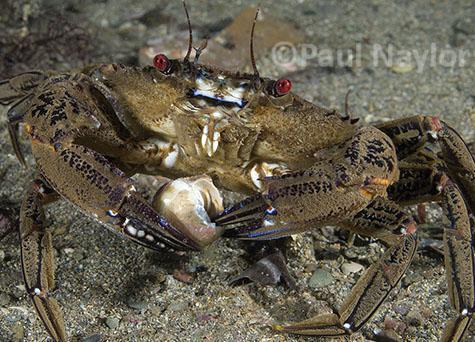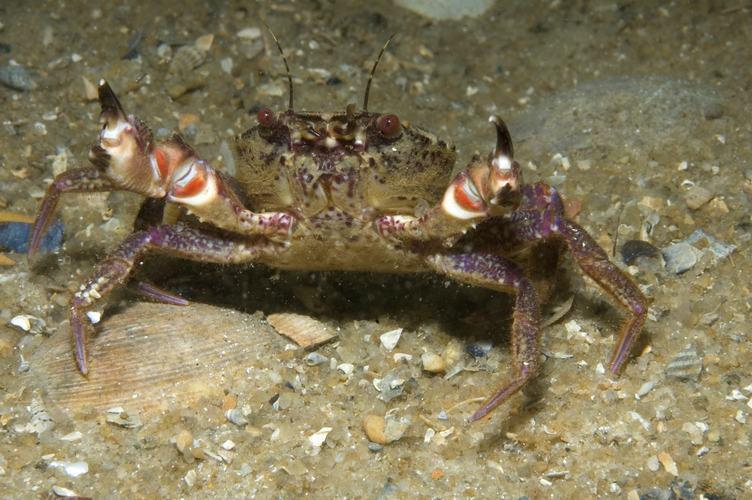The first image is the image on the left, the second image is the image on the right. Evaluate the accuracy of this statement regarding the images: "Three pairs of eyes are visible.". Is it true? Answer yes or no. No. 